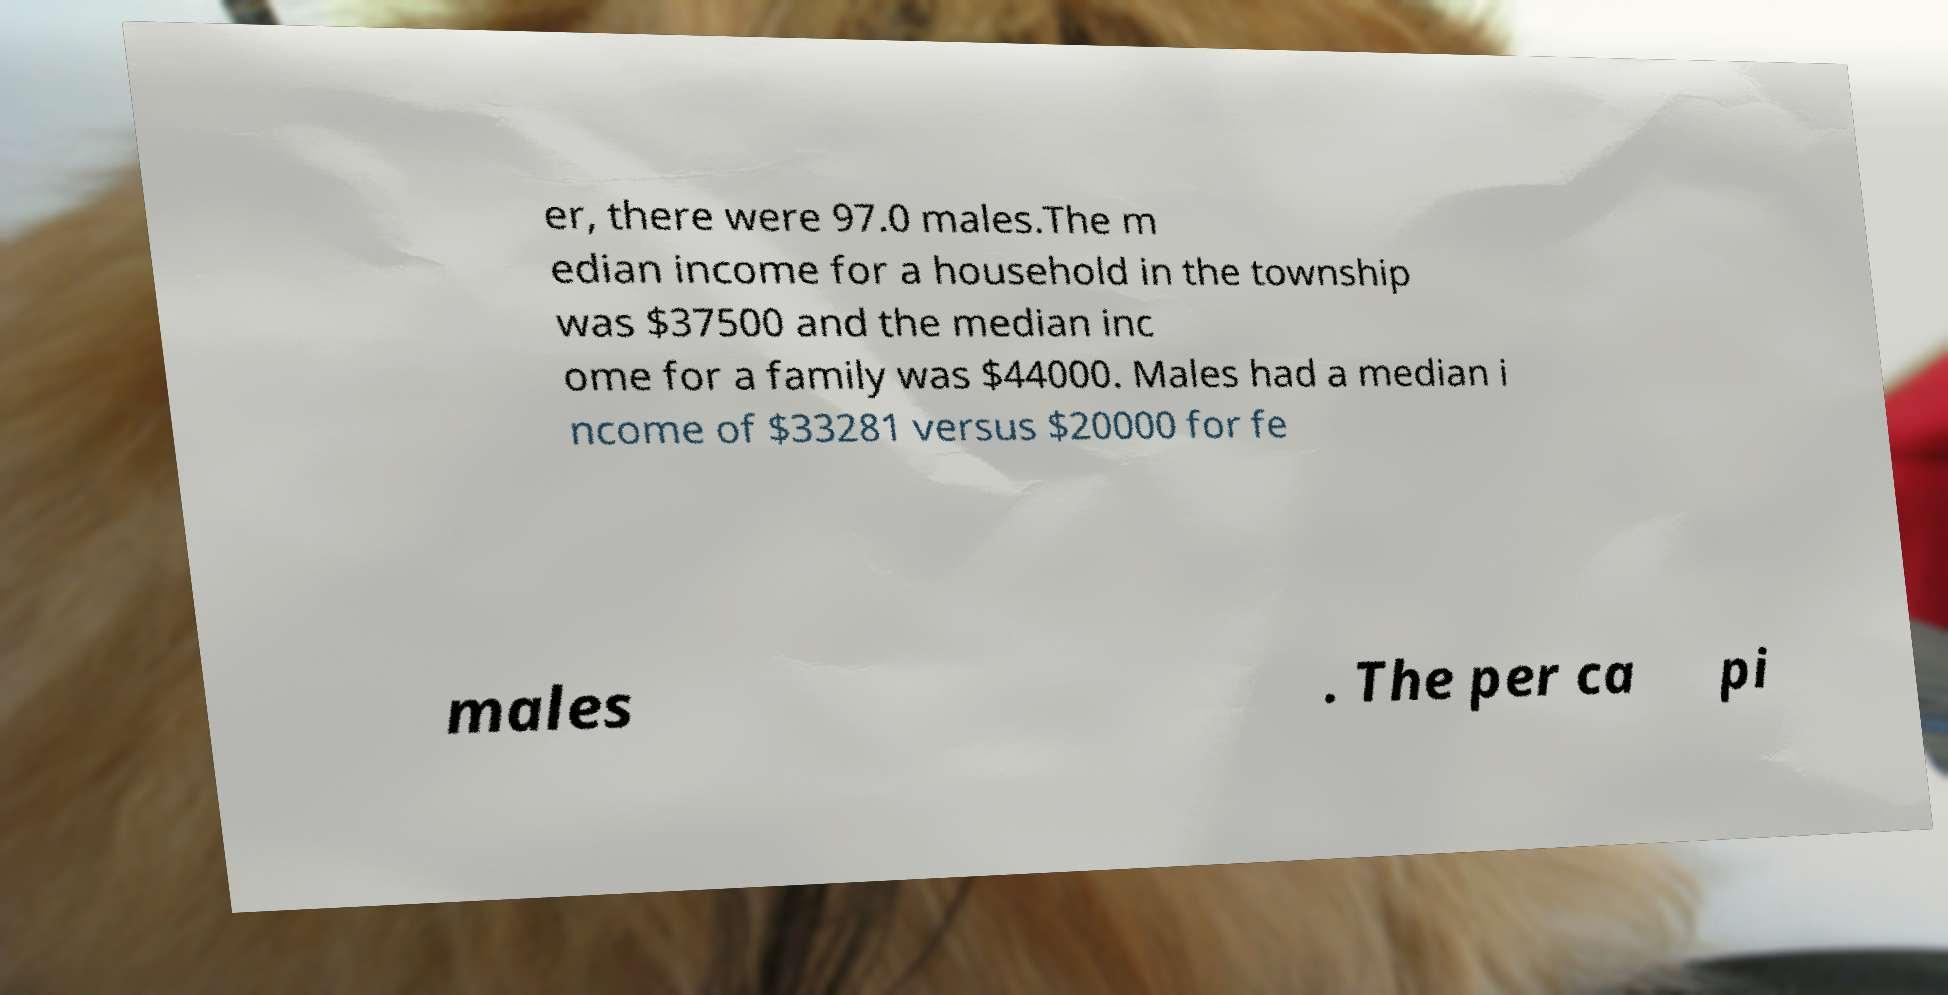Please identify and transcribe the text found in this image. er, there were 97.0 males.The m edian income for a household in the township was $37500 and the median inc ome for a family was $44000. Males had a median i ncome of $33281 versus $20000 for fe males . The per ca pi 